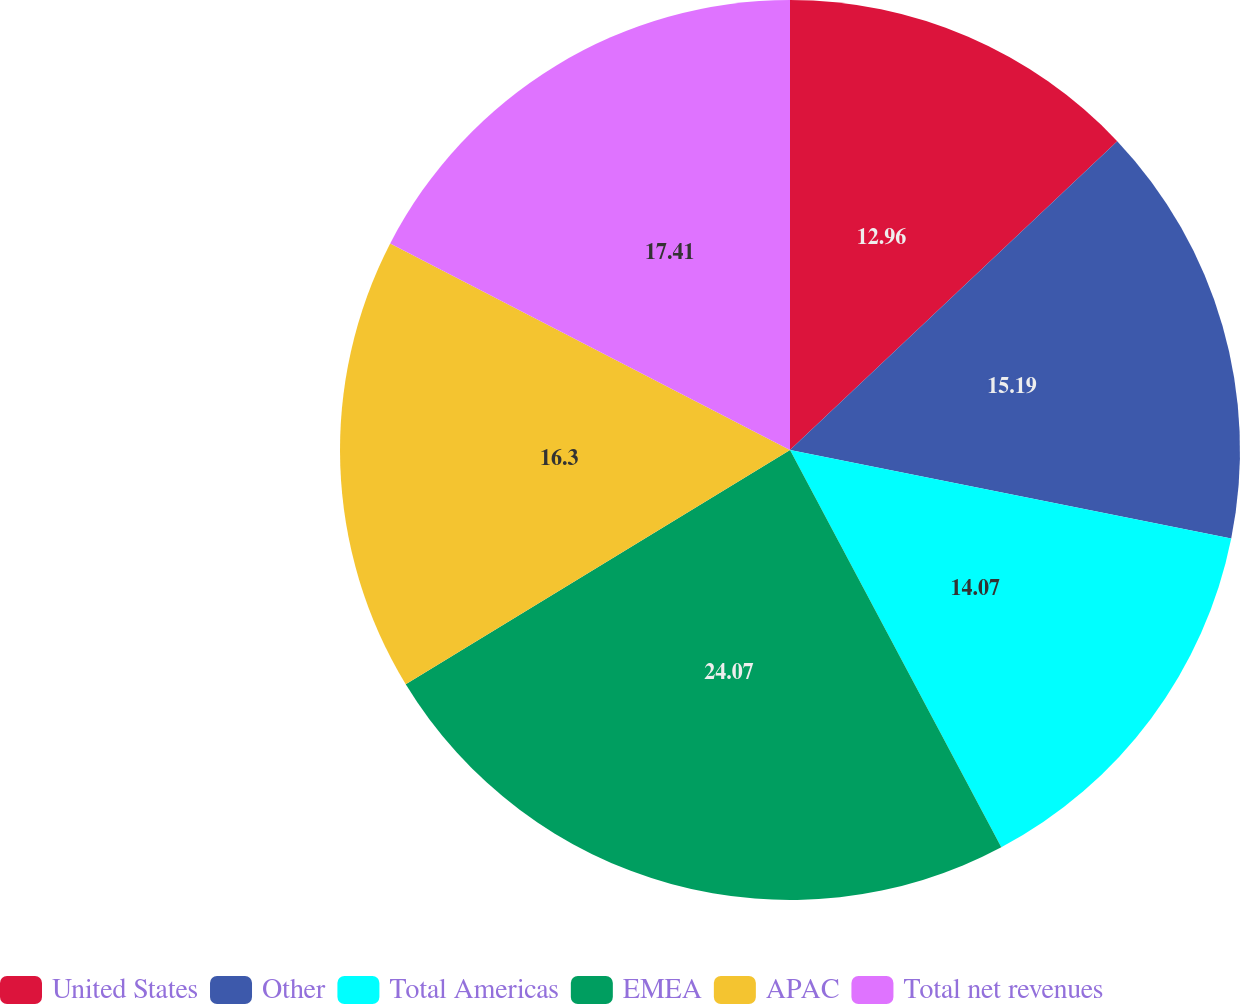Convert chart. <chart><loc_0><loc_0><loc_500><loc_500><pie_chart><fcel>United States<fcel>Other<fcel>Total Americas<fcel>EMEA<fcel>APAC<fcel>Total net revenues<nl><fcel>12.96%<fcel>15.19%<fcel>14.07%<fcel>24.07%<fcel>16.3%<fcel>17.41%<nl></chart> 